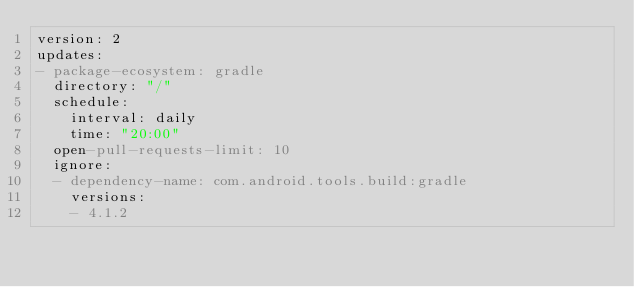Convert code to text. <code><loc_0><loc_0><loc_500><loc_500><_YAML_>version: 2
updates:
- package-ecosystem: gradle
  directory: "/"
  schedule:
    interval: daily
    time: "20:00"
  open-pull-requests-limit: 10
  ignore:
  - dependency-name: com.android.tools.build:gradle
    versions:
    - 4.1.2
</code> 